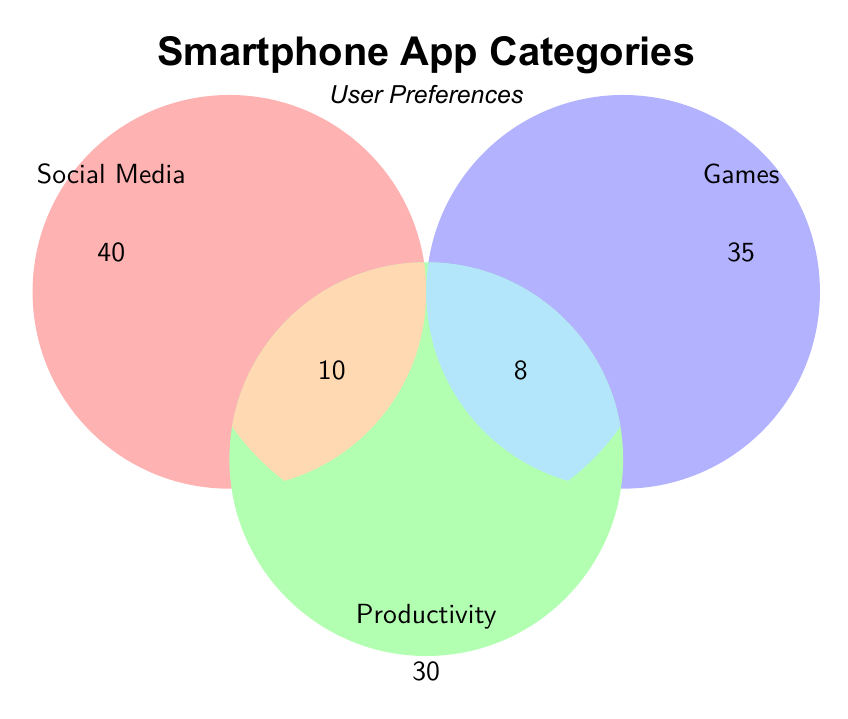What is the total number of users who prefer Social Media? From the figure, the total includes individual Social Media users (40), Social Media & Games (15), Social Media & Productivity (10), and All Categories (5). So, the total is 40 + 15 + 10 + 5.
Answer: 70 Which category has the least number of users showing in the diagram? The Productivity circle has 30 users, Games has 35, and Social Media has 40. Comparatively, Productivity has the least.
Answer: Productivity How many users prefer both Games and Productivity but not Social Media? Referring to the figure, the segment where Games and Productivity overlap without Social Media is marked as 8.
Answer: 8 How many users prefer all three categories? The central overlap of all three categories (Social Media, Games, and Productivity) is marked 5.
Answer: 5 How many users prefer at least two categories? Users preferring at least two categories are in the overlap areas: 15 (Social Media & Games) + 10 (Social Media & Productivity) + 8 (Games & Productivity) + 5 (All Categories). Adding them gives 15 + 10 + 8 + 5.
Answer: 38 Which overlap has more users, Social Media & Games, or Social Media & Productivity? The figure shows Social Media & Games overlap with 15 users and Social Media & Productivity with 10 users. So, Social Media & Games has more.
Answer: Social Media & Games Calculate the number of users who prefer only one category. Users who prefer only one category are:
Social Media: 40 - (15 + 10 + 5) = 10
Games: 35 - (15 + 8 + 5) = 7
Productivity: 30 - (10 + 8 + 5) = 7
Adding these gives 10 + 7 + 7.
Answer: 24 What is the total number of users represented in the Venn Diagram? The sum of all distinct categories is 45 (only Social Media) + 30 (only Games) + 25 (only Productivity) - (15 + 10 + 8) + 5 (overlap of all three categories):
Thus, the total is 70.
Answer: 70 If a user prefers Social Media, what is the probability they also prefer Games? Users who prefer Social Media and Games are 15, and the total Social Media users are 70. The probability is 15/70.
Answer: 21.43% 